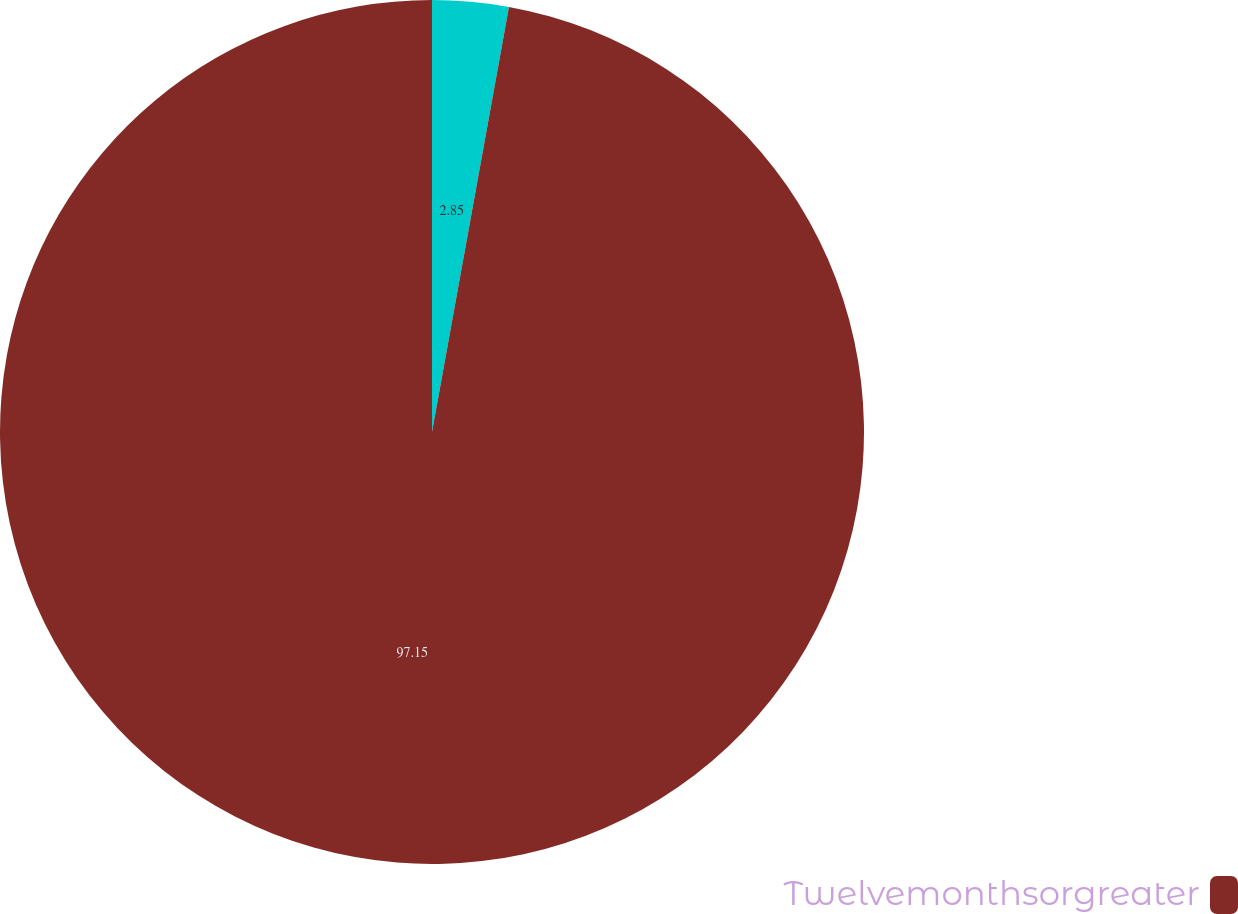Convert chart. <chart><loc_0><loc_0><loc_500><loc_500><pie_chart><ecel><fcel>Twelvemonthsorgreater<nl><fcel>2.85%<fcel>97.15%<nl></chart> 